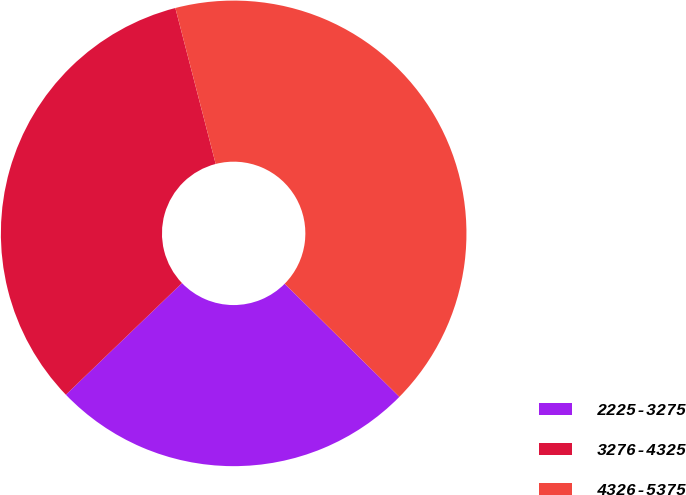<chart> <loc_0><loc_0><loc_500><loc_500><pie_chart><fcel>2225-3275<fcel>3276-4325<fcel>4326-5375<nl><fcel>25.42%<fcel>33.16%<fcel>41.42%<nl></chart> 